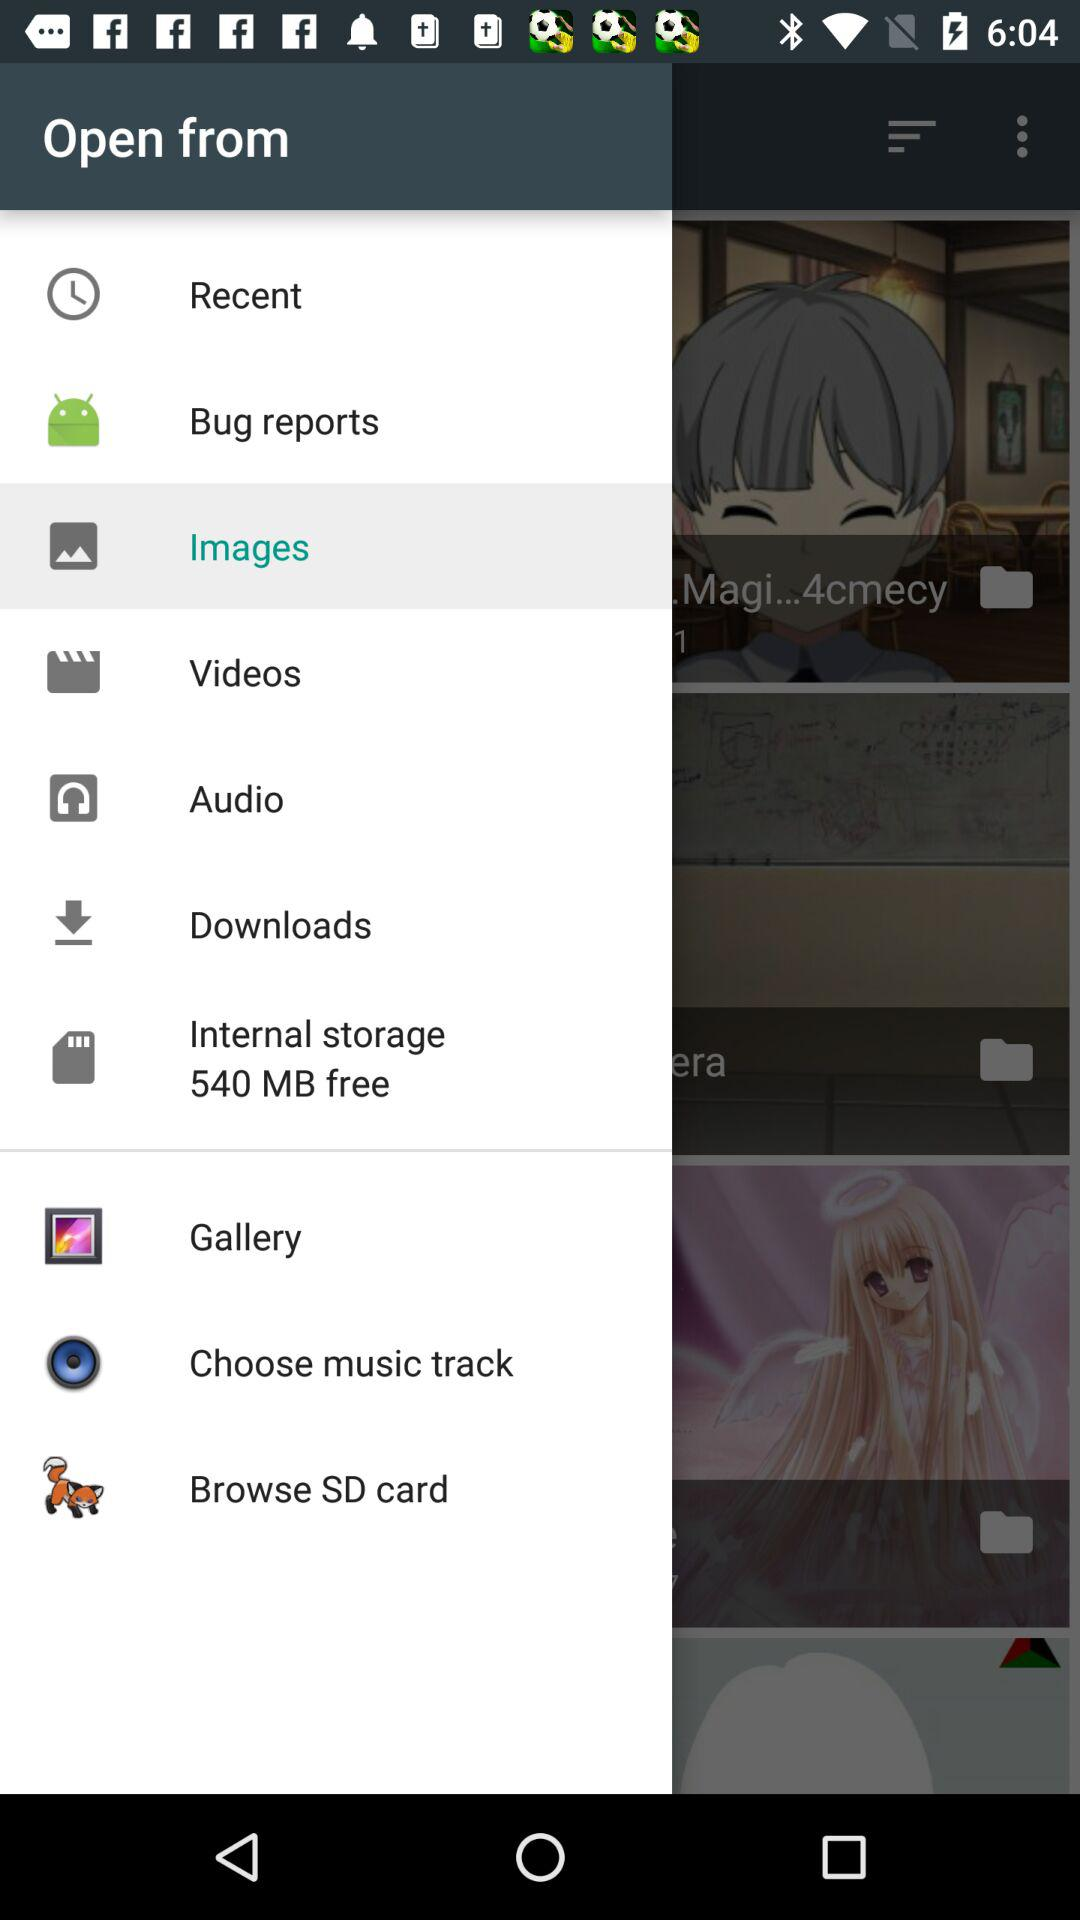How many notifications are there in "Downloads"?
When the provided information is insufficient, respond with <no answer>. <no answer> 